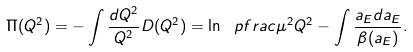Convert formula to latex. <formula><loc_0><loc_0><loc_500><loc_500>\Pi ( Q ^ { 2 } ) = - \int \frac { d Q ^ { 2 } } { Q ^ { 2 } } D ( Q ^ { 2 } ) = \ln \ p f r a c { \mu ^ { 2 } } { Q ^ { 2 } } - \int \frac { a _ { E } d a _ { E } } { \beta ( a _ { E } ) } .</formula> 